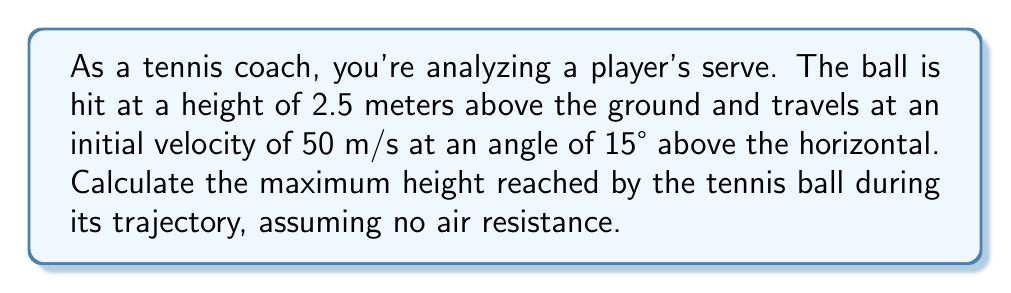Could you help me with this problem? Let's approach this step-by-step using trigonometric equations:

1) First, we need to find the vertical component of the initial velocity:
   $v_y = v \sin\theta = 50 \sin(15°) = 12.94$ m/s

2) The time to reach the maximum height can be calculated using the equation:
   $t = \frac{v_y}{g}$, where $g$ is the acceleration due to gravity (9.8 m/s²)
   
   $t = \frac{12.94}{9.8} = 1.32$ seconds

3) Now, we can calculate the maximum height reached above the initial height using the equation:
   $h = \frac{v_y^2}{2g}$

   $h = \frac{(12.94)^2}{2(9.8)} = 8.55$ meters

4) However, this is the height above the initial point. We need to add the initial height to get the total maximum height:

   Total maximum height = Initial height + Maximum height reached
   $H = 2.5 + 8.55 = 11.05$ meters

Therefore, the tennis ball reaches a maximum height of 11.05 meters above the ground.
Answer: 11.05 meters 